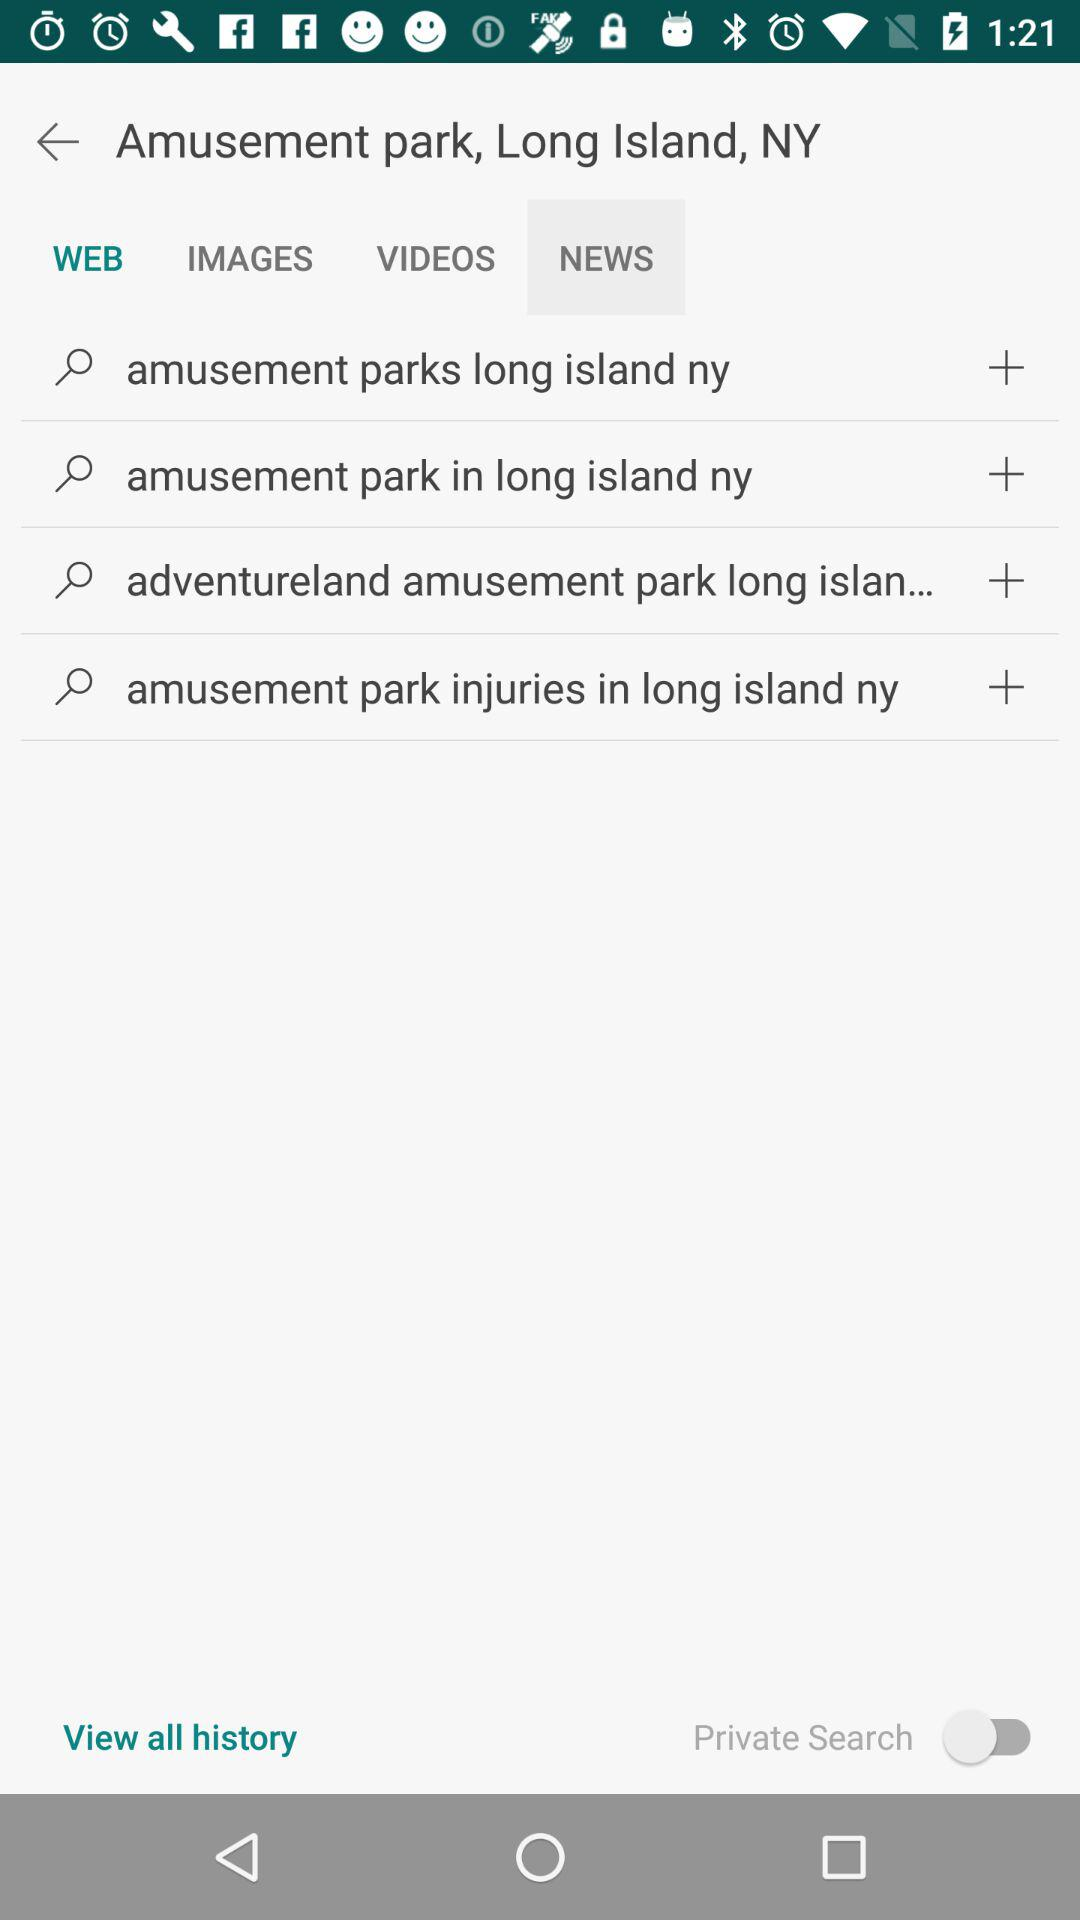What is the status of "Private Search"? The status is "off". 